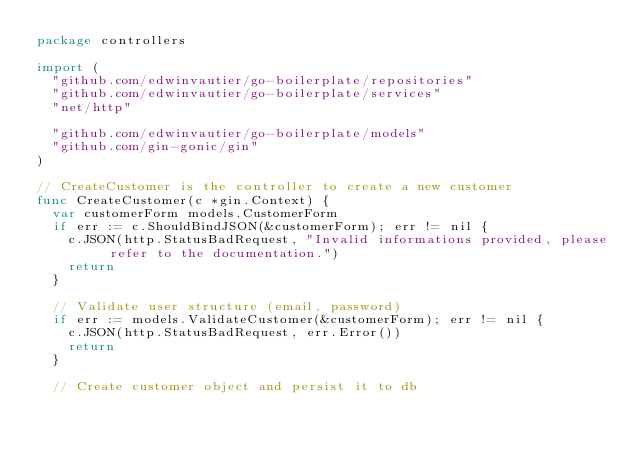<code> <loc_0><loc_0><loc_500><loc_500><_Go_>package controllers

import (
	"github.com/edwinvautier/go-boilerplate/repositories"
	"github.com/edwinvautier/go-boilerplate/services"
	"net/http"

	"github.com/edwinvautier/go-boilerplate/models"
	"github.com/gin-gonic/gin"
)

// CreateCustomer is the controller to create a new customer
func CreateCustomer(c *gin.Context) {
	var customerForm models.CustomerForm
	if err := c.ShouldBindJSON(&customerForm); err != nil {
		c.JSON(http.StatusBadRequest, "Invalid informations provided, please refer to the documentation.")
		return
	}

	// Validate user structure (email, password)
	if err := models.ValidateCustomer(&customerForm); err != nil {
		c.JSON(http.StatusBadRequest, err.Error())
		return
	}

	// Create customer object and persist it to db</code> 